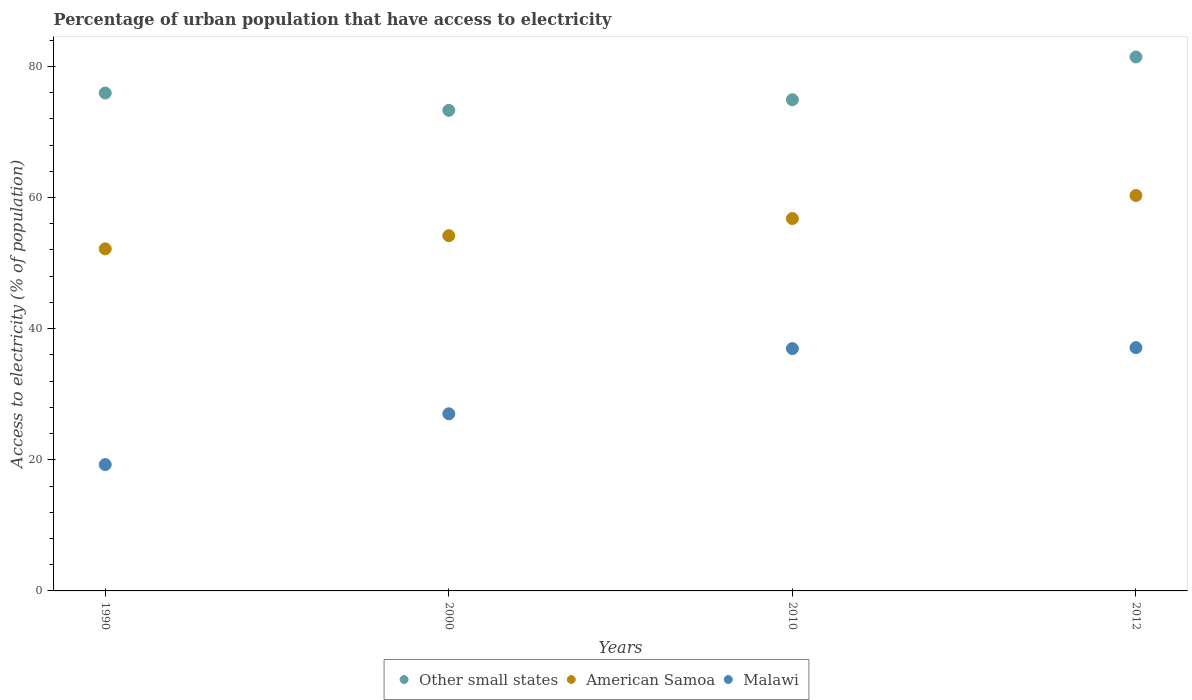How many different coloured dotlines are there?
Offer a very short reply. 3. Is the number of dotlines equal to the number of legend labels?
Make the answer very short. Yes. What is the percentage of urban population that have access to electricity in American Samoa in 2010?
Your answer should be very brief. 56.79. Across all years, what is the maximum percentage of urban population that have access to electricity in Malawi?
Keep it short and to the point. 37.1. Across all years, what is the minimum percentage of urban population that have access to electricity in Malawi?
Give a very brief answer. 19.27. In which year was the percentage of urban population that have access to electricity in Other small states maximum?
Provide a short and direct response. 2012. What is the total percentage of urban population that have access to electricity in Malawi in the graph?
Ensure brevity in your answer.  120.33. What is the difference between the percentage of urban population that have access to electricity in Malawi in 2000 and that in 2010?
Ensure brevity in your answer.  -9.95. What is the difference between the percentage of urban population that have access to electricity in Malawi in 2010 and the percentage of urban population that have access to electricity in Other small states in 2012?
Give a very brief answer. -44.48. What is the average percentage of urban population that have access to electricity in American Samoa per year?
Provide a short and direct response. 55.86. In the year 1990, what is the difference between the percentage of urban population that have access to electricity in American Samoa and percentage of urban population that have access to electricity in Malawi?
Ensure brevity in your answer.  32.9. In how many years, is the percentage of urban population that have access to electricity in American Samoa greater than 72 %?
Offer a terse response. 0. What is the ratio of the percentage of urban population that have access to electricity in Other small states in 2000 to that in 2010?
Make the answer very short. 0.98. What is the difference between the highest and the second highest percentage of urban population that have access to electricity in American Samoa?
Your response must be concise. 3.52. What is the difference between the highest and the lowest percentage of urban population that have access to electricity in Other small states?
Provide a short and direct response. 8.14. In how many years, is the percentage of urban population that have access to electricity in Malawi greater than the average percentage of urban population that have access to electricity in Malawi taken over all years?
Offer a very short reply. 2. Is the sum of the percentage of urban population that have access to electricity in Other small states in 1990 and 2012 greater than the maximum percentage of urban population that have access to electricity in Malawi across all years?
Provide a succinct answer. Yes. Is it the case that in every year, the sum of the percentage of urban population that have access to electricity in Malawi and percentage of urban population that have access to electricity in Other small states  is greater than the percentage of urban population that have access to electricity in American Samoa?
Provide a short and direct response. Yes. Does the percentage of urban population that have access to electricity in Other small states monotonically increase over the years?
Ensure brevity in your answer.  No. Is the percentage of urban population that have access to electricity in American Samoa strictly less than the percentage of urban population that have access to electricity in Other small states over the years?
Offer a very short reply. Yes. How many dotlines are there?
Your response must be concise. 3. Are the values on the major ticks of Y-axis written in scientific E-notation?
Provide a succinct answer. No. Where does the legend appear in the graph?
Your answer should be very brief. Bottom center. What is the title of the graph?
Offer a very short reply. Percentage of urban population that have access to electricity. Does "Dominica" appear as one of the legend labels in the graph?
Provide a succinct answer. No. What is the label or title of the Y-axis?
Keep it short and to the point. Access to electricity (% of population). What is the Access to electricity (% of population) in Other small states in 1990?
Your answer should be compact. 75.93. What is the Access to electricity (% of population) in American Samoa in 1990?
Give a very brief answer. 52.17. What is the Access to electricity (% of population) of Malawi in 1990?
Offer a terse response. 19.27. What is the Access to electricity (% of population) of Other small states in 2000?
Give a very brief answer. 73.29. What is the Access to electricity (% of population) of American Samoa in 2000?
Offer a very short reply. 54.18. What is the Access to electricity (% of population) in Malawi in 2000?
Offer a very short reply. 27.01. What is the Access to electricity (% of population) in Other small states in 2010?
Give a very brief answer. 74.91. What is the Access to electricity (% of population) in American Samoa in 2010?
Your answer should be very brief. 56.79. What is the Access to electricity (% of population) in Malawi in 2010?
Provide a succinct answer. 36.96. What is the Access to electricity (% of population) of Other small states in 2012?
Provide a succinct answer. 81.43. What is the Access to electricity (% of population) of American Samoa in 2012?
Offer a terse response. 60.3. What is the Access to electricity (% of population) of Malawi in 2012?
Keep it short and to the point. 37.1. Across all years, what is the maximum Access to electricity (% of population) in Other small states?
Your answer should be very brief. 81.43. Across all years, what is the maximum Access to electricity (% of population) in American Samoa?
Make the answer very short. 60.3. Across all years, what is the maximum Access to electricity (% of population) in Malawi?
Your response must be concise. 37.1. Across all years, what is the minimum Access to electricity (% of population) in Other small states?
Make the answer very short. 73.29. Across all years, what is the minimum Access to electricity (% of population) in American Samoa?
Give a very brief answer. 52.17. Across all years, what is the minimum Access to electricity (% of population) of Malawi?
Make the answer very short. 19.27. What is the total Access to electricity (% of population) of Other small states in the graph?
Provide a succinct answer. 305.56. What is the total Access to electricity (% of population) in American Samoa in the graph?
Give a very brief answer. 223.44. What is the total Access to electricity (% of population) in Malawi in the graph?
Keep it short and to the point. 120.33. What is the difference between the Access to electricity (% of population) in Other small states in 1990 and that in 2000?
Offer a very short reply. 2.64. What is the difference between the Access to electricity (% of population) in American Samoa in 1990 and that in 2000?
Offer a very short reply. -2.01. What is the difference between the Access to electricity (% of population) in Malawi in 1990 and that in 2000?
Your answer should be very brief. -7.74. What is the difference between the Access to electricity (% of population) in Other small states in 1990 and that in 2010?
Keep it short and to the point. 1.02. What is the difference between the Access to electricity (% of population) in American Samoa in 1990 and that in 2010?
Offer a very short reply. -4.62. What is the difference between the Access to electricity (% of population) of Malawi in 1990 and that in 2010?
Give a very brief answer. -17.69. What is the difference between the Access to electricity (% of population) in Other small states in 1990 and that in 2012?
Ensure brevity in your answer.  -5.5. What is the difference between the Access to electricity (% of population) in American Samoa in 1990 and that in 2012?
Your response must be concise. -8.14. What is the difference between the Access to electricity (% of population) of Malawi in 1990 and that in 2012?
Give a very brief answer. -17.83. What is the difference between the Access to electricity (% of population) in Other small states in 2000 and that in 2010?
Make the answer very short. -1.62. What is the difference between the Access to electricity (% of population) in American Samoa in 2000 and that in 2010?
Offer a very short reply. -2.61. What is the difference between the Access to electricity (% of population) in Malawi in 2000 and that in 2010?
Ensure brevity in your answer.  -9.95. What is the difference between the Access to electricity (% of population) in Other small states in 2000 and that in 2012?
Provide a short and direct response. -8.14. What is the difference between the Access to electricity (% of population) of American Samoa in 2000 and that in 2012?
Ensure brevity in your answer.  -6.13. What is the difference between the Access to electricity (% of population) of Malawi in 2000 and that in 2012?
Your answer should be compact. -10.09. What is the difference between the Access to electricity (% of population) in Other small states in 2010 and that in 2012?
Your response must be concise. -6.52. What is the difference between the Access to electricity (% of population) in American Samoa in 2010 and that in 2012?
Provide a succinct answer. -3.52. What is the difference between the Access to electricity (% of population) in Malawi in 2010 and that in 2012?
Give a very brief answer. -0.14. What is the difference between the Access to electricity (% of population) in Other small states in 1990 and the Access to electricity (% of population) in American Samoa in 2000?
Make the answer very short. 21.76. What is the difference between the Access to electricity (% of population) in Other small states in 1990 and the Access to electricity (% of population) in Malawi in 2000?
Provide a short and direct response. 48.92. What is the difference between the Access to electricity (% of population) in American Samoa in 1990 and the Access to electricity (% of population) in Malawi in 2000?
Ensure brevity in your answer.  25.16. What is the difference between the Access to electricity (% of population) of Other small states in 1990 and the Access to electricity (% of population) of American Samoa in 2010?
Offer a terse response. 19.14. What is the difference between the Access to electricity (% of population) of Other small states in 1990 and the Access to electricity (% of population) of Malawi in 2010?
Keep it short and to the point. 38.98. What is the difference between the Access to electricity (% of population) in American Samoa in 1990 and the Access to electricity (% of population) in Malawi in 2010?
Give a very brief answer. 15.21. What is the difference between the Access to electricity (% of population) of Other small states in 1990 and the Access to electricity (% of population) of American Samoa in 2012?
Give a very brief answer. 15.63. What is the difference between the Access to electricity (% of population) in Other small states in 1990 and the Access to electricity (% of population) in Malawi in 2012?
Make the answer very short. 38.83. What is the difference between the Access to electricity (% of population) in American Samoa in 1990 and the Access to electricity (% of population) in Malawi in 2012?
Offer a very short reply. 15.07. What is the difference between the Access to electricity (% of population) in Other small states in 2000 and the Access to electricity (% of population) in American Samoa in 2010?
Offer a terse response. 16.5. What is the difference between the Access to electricity (% of population) in Other small states in 2000 and the Access to electricity (% of population) in Malawi in 2010?
Keep it short and to the point. 36.34. What is the difference between the Access to electricity (% of population) in American Samoa in 2000 and the Access to electricity (% of population) in Malawi in 2010?
Your response must be concise. 17.22. What is the difference between the Access to electricity (% of population) in Other small states in 2000 and the Access to electricity (% of population) in American Samoa in 2012?
Offer a terse response. 12.99. What is the difference between the Access to electricity (% of population) of Other small states in 2000 and the Access to electricity (% of population) of Malawi in 2012?
Provide a succinct answer. 36.19. What is the difference between the Access to electricity (% of population) of American Samoa in 2000 and the Access to electricity (% of population) of Malawi in 2012?
Offer a terse response. 17.08. What is the difference between the Access to electricity (% of population) of Other small states in 2010 and the Access to electricity (% of population) of American Samoa in 2012?
Offer a very short reply. 14.6. What is the difference between the Access to electricity (% of population) of Other small states in 2010 and the Access to electricity (% of population) of Malawi in 2012?
Provide a succinct answer. 37.81. What is the difference between the Access to electricity (% of population) in American Samoa in 2010 and the Access to electricity (% of population) in Malawi in 2012?
Provide a short and direct response. 19.69. What is the average Access to electricity (% of population) in Other small states per year?
Provide a short and direct response. 76.39. What is the average Access to electricity (% of population) of American Samoa per year?
Your answer should be very brief. 55.86. What is the average Access to electricity (% of population) in Malawi per year?
Make the answer very short. 30.08. In the year 1990, what is the difference between the Access to electricity (% of population) of Other small states and Access to electricity (% of population) of American Samoa?
Offer a terse response. 23.76. In the year 1990, what is the difference between the Access to electricity (% of population) of Other small states and Access to electricity (% of population) of Malawi?
Offer a terse response. 56.67. In the year 1990, what is the difference between the Access to electricity (% of population) of American Samoa and Access to electricity (% of population) of Malawi?
Your answer should be very brief. 32.9. In the year 2000, what is the difference between the Access to electricity (% of population) of Other small states and Access to electricity (% of population) of American Samoa?
Provide a short and direct response. 19.12. In the year 2000, what is the difference between the Access to electricity (% of population) of Other small states and Access to electricity (% of population) of Malawi?
Offer a very short reply. 46.28. In the year 2000, what is the difference between the Access to electricity (% of population) in American Samoa and Access to electricity (% of population) in Malawi?
Keep it short and to the point. 27.17. In the year 2010, what is the difference between the Access to electricity (% of population) in Other small states and Access to electricity (% of population) in American Samoa?
Offer a very short reply. 18.12. In the year 2010, what is the difference between the Access to electricity (% of population) in Other small states and Access to electricity (% of population) in Malawi?
Give a very brief answer. 37.95. In the year 2010, what is the difference between the Access to electricity (% of population) in American Samoa and Access to electricity (% of population) in Malawi?
Keep it short and to the point. 19.83. In the year 2012, what is the difference between the Access to electricity (% of population) in Other small states and Access to electricity (% of population) in American Samoa?
Make the answer very short. 21.13. In the year 2012, what is the difference between the Access to electricity (% of population) of Other small states and Access to electricity (% of population) of Malawi?
Offer a terse response. 44.33. In the year 2012, what is the difference between the Access to electricity (% of population) of American Samoa and Access to electricity (% of population) of Malawi?
Provide a short and direct response. 23.2. What is the ratio of the Access to electricity (% of population) in Other small states in 1990 to that in 2000?
Offer a very short reply. 1.04. What is the ratio of the Access to electricity (% of population) in American Samoa in 1990 to that in 2000?
Offer a terse response. 0.96. What is the ratio of the Access to electricity (% of population) in Malawi in 1990 to that in 2000?
Offer a very short reply. 0.71. What is the ratio of the Access to electricity (% of population) of Other small states in 1990 to that in 2010?
Give a very brief answer. 1.01. What is the ratio of the Access to electricity (% of population) in American Samoa in 1990 to that in 2010?
Give a very brief answer. 0.92. What is the ratio of the Access to electricity (% of population) in Malawi in 1990 to that in 2010?
Offer a terse response. 0.52. What is the ratio of the Access to electricity (% of population) of Other small states in 1990 to that in 2012?
Make the answer very short. 0.93. What is the ratio of the Access to electricity (% of population) in American Samoa in 1990 to that in 2012?
Offer a terse response. 0.87. What is the ratio of the Access to electricity (% of population) of Malawi in 1990 to that in 2012?
Your answer should be very brief. 0.52. What is the ratio of the Access to electricity (% of population) in Other small states in 2000 to that in 2010?
Provide a succinct answer. 0.98. What is the ratio of the Access to electricity (% of population) in American Samoa in 2000 to that in 2010?
Your answer should be very brief. 0.95. What is the ratio of the Access to electricity (% of population) in Malawi in 2000 to that in 2010?
Provide a short and direct response. 0.73. What is the ratio of the Access to electricity (% of population) in American Samoa in 2000 to that in 2012?
Give a very brief answer. 0.9. What is the ratio of the Access to electricity (% of population) in Malawi in 2000 to that in 2012?
Your answer should be very brief. 0.73. What is the ratio of the Access to electricity (% of population) of Other small states in 2010 to that in 2012?
Give a very brief answer. 0.92. What is the ratio of the Access to electricity (% of population) of American Samoa in 2010 to that in 2012?
Your response must be concise. 0.94. What is the difference between the highest and the second highest Access to electricity (% of population) of Other small states?
Keep it short and to the point. 5.5. What is the difference between the highest and the second highest Access to electricity (% of population) in American Samoa?
Your response must be concise. 3.52. What is the difference between the highest and the second highest Access to electricity (% of population) in Malawi?
Your response must be concise. 0.14. What is the difference between the highest and the lowest Access to electricity (% of population) in Other small states?
Your answer should be compact. 8.14. What is the difference between the highest and the lowest Access to electricity (% of population) of American Samoa?
Your response must be concise. 8.14. What is the difference between the highest and the lowest Access to electricity (% of population) in Malawi?
Offer a terse response. 17.83. 